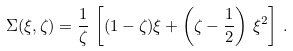Convert formula to latex. <formula><loc_0><loc_0><loc_500><loc_500>\Sigma ( \xi , \zeta ) = \frac { 1 } { \zeta } \, \left [ ( 1 - \zeta ) \xi + \left ( \zeta - \frac { 1 } { 2 } \right ) \, \xi ^ { 2 } \right ] \, .</formula> 